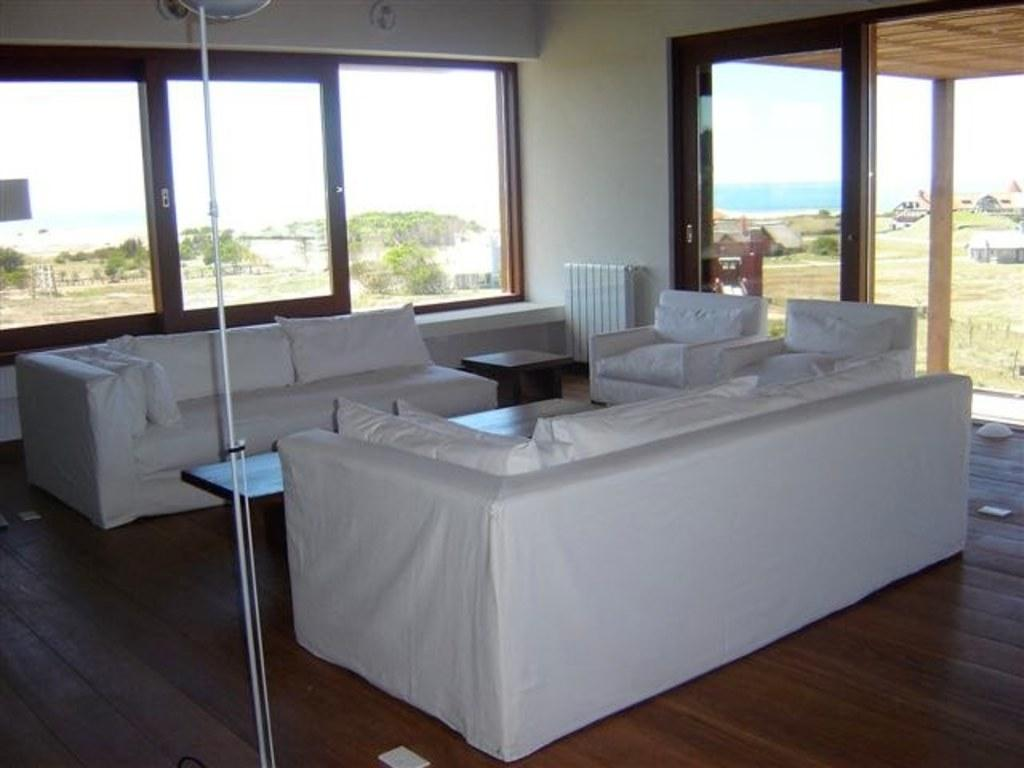What type of space is depicted in the image? There is a room in the image. What type of furniture is present in the room? There is a sofa, chairs, and tables in the room. What other object can be seen in the room? There is a pole in the room. What can be seen through the windows in the room? The sky, trees, land, and houses are visible through the windows. What is the price of the sofa in the image? The price of the sofa is not visible in the image, as it only shows the appearance of the room and its contents. 